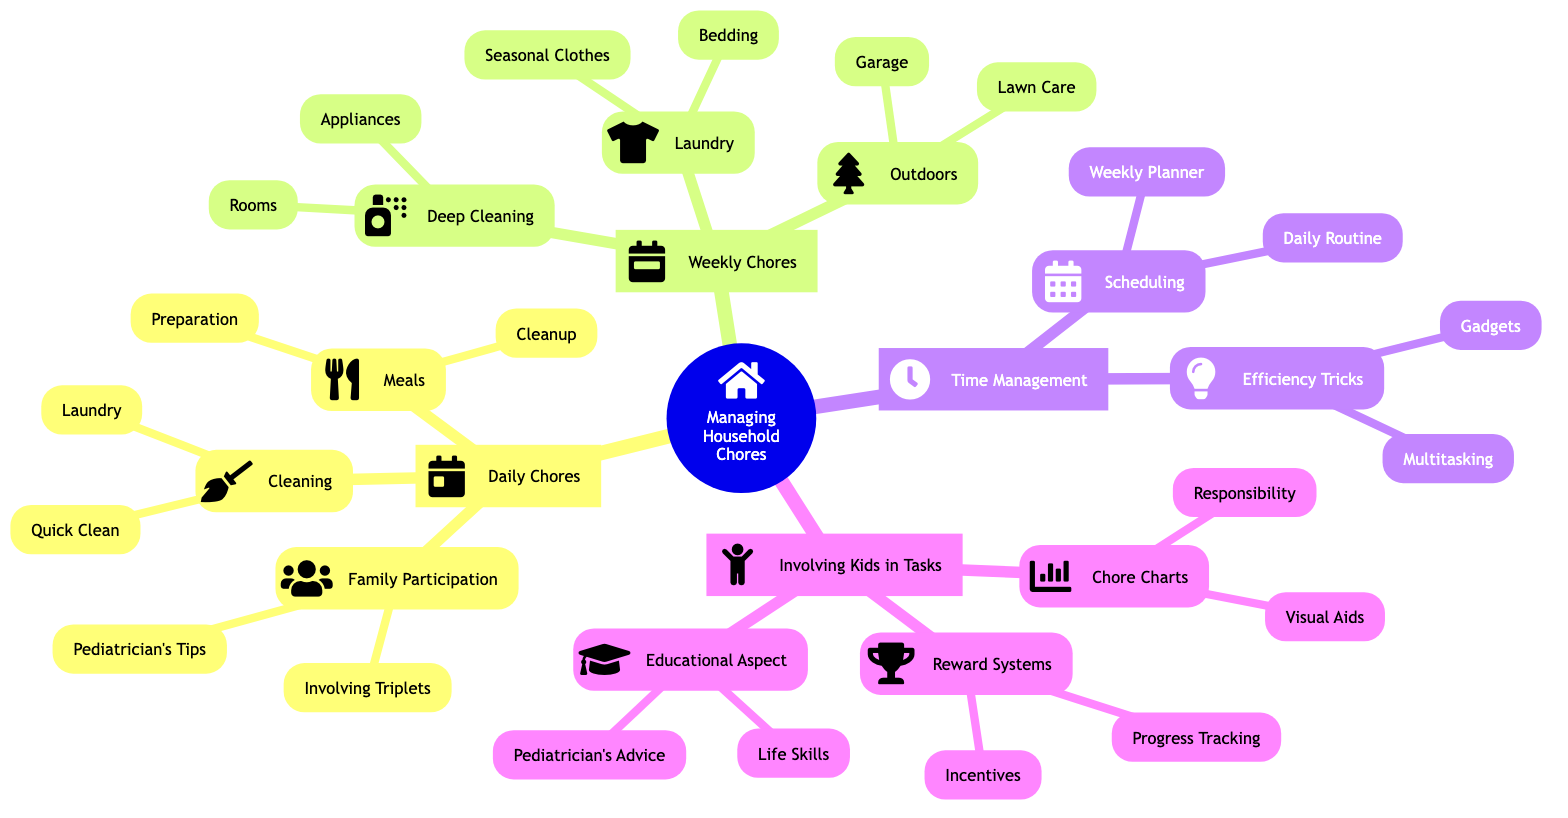What's the first category listed under "Managing Household Chores Efficiently"? The first category under "Managing Household Chores Efficiently" is "Daily Chores". This can be found directly beneath the main node in the mind map.
Answer: Daily Chores How many chores are listed under "Daily Chores"? In the mind map, there are three main sections under "Daily Chores": Meals, Cleaning, and Family Participation. Therefore, there are three chores listed.
Answer: 3 Which chore involves the triplets directly? The triplets are involved in the task of "Setting Table" as per the "Involving Triplets" section under "Family Participation". This connection indicates their direct engagement in one of the household chores.
Answer: Setting Table What are the two main components of the "Time Management" category? The two main components under "Time Management" are "Scheduling" and "Efficiency Tricks". They represent the key areas of focus for managing time effectively in household chores as shown in the diagram.
Answer: Scheduling, Efficiency Tricks Which chores are categorized under "Deep Cleaning"? The "Deep Cleaning" category includes "Rooms" and "Appliances" as specified in the mind map. These indicate specific areas that require thorough cleaning on a weekly basis.
Answer: Rooms, Appliances How do "Reward Systems" help in involving kids in household tasks? "Reward Systems" provide "Incentives" and "Progress Tracking", which are designed to encourage children’s participation in chores. This shows that rewards and tracking progress can reinforce their involvement in household tasks.
Answer: Incentives, Progress Tracking What is one efficiency trick related to multitasking? One efficiency trick related to multitasking mentioned in the mind map is "Fold Laundry During Nap Time". This suggests a method to use time effectively while managing household chores.
Answer: Fold Laundry During Nap Time How many types of visual aids are listed under "Chore Charts"? There are two types of visual aids listed under "Chore Charts": "Sticker Charts" and "Magnet Boards". This adds clarity on how to visually manage responsibilities for kids.
Answer: 2 What are the age-appropriate tasks mentioned by the pediatrician? The pediatrician emphasizes "Age-Appropriate Tasks" under the "Pediatrician's Tips" node in "Family Participation". This suggests that tasks should be tailored according to the children's age to engage them appropriately.
Answer: Age-Appropriate Tasks 